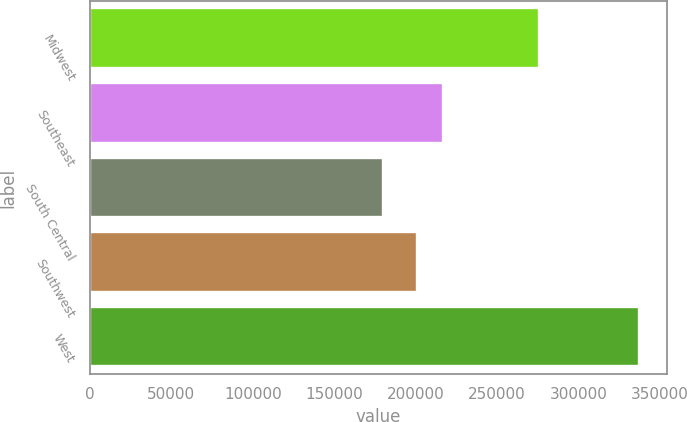<chart> <loc_0><loc_0><loc_500><loc_500><bar_chart><fcel>Midwest<fcel>Southeast<fcel>South Central<fcel>Southwest<fcel>West<nl><fcel>276000<fcel>216670<fcel>179700<fcel>200900<fcel>337400<nl></chart> 